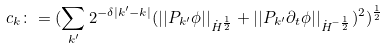<formula> <loc_0><loc_0><loc_500><loc_500>c _ { k } \colon = ( \sum _ { k ^ { \prime } } 2 ^ { - \delta | k ^ { \prime } - k | } ( | | P _ { k ^ { \prime } } \phi | | _ { \dot { H } ^ { \frac { 1 } { 2 } } } + | | P _ { k ^ { \prime } } \partial _ { t } \phi | | _ { \dot { H } ^ { - \frac { 1 } { 2 } } } ) ^ { 2 } ) ^ { \frac { 1 } { 2 } }</formula> 